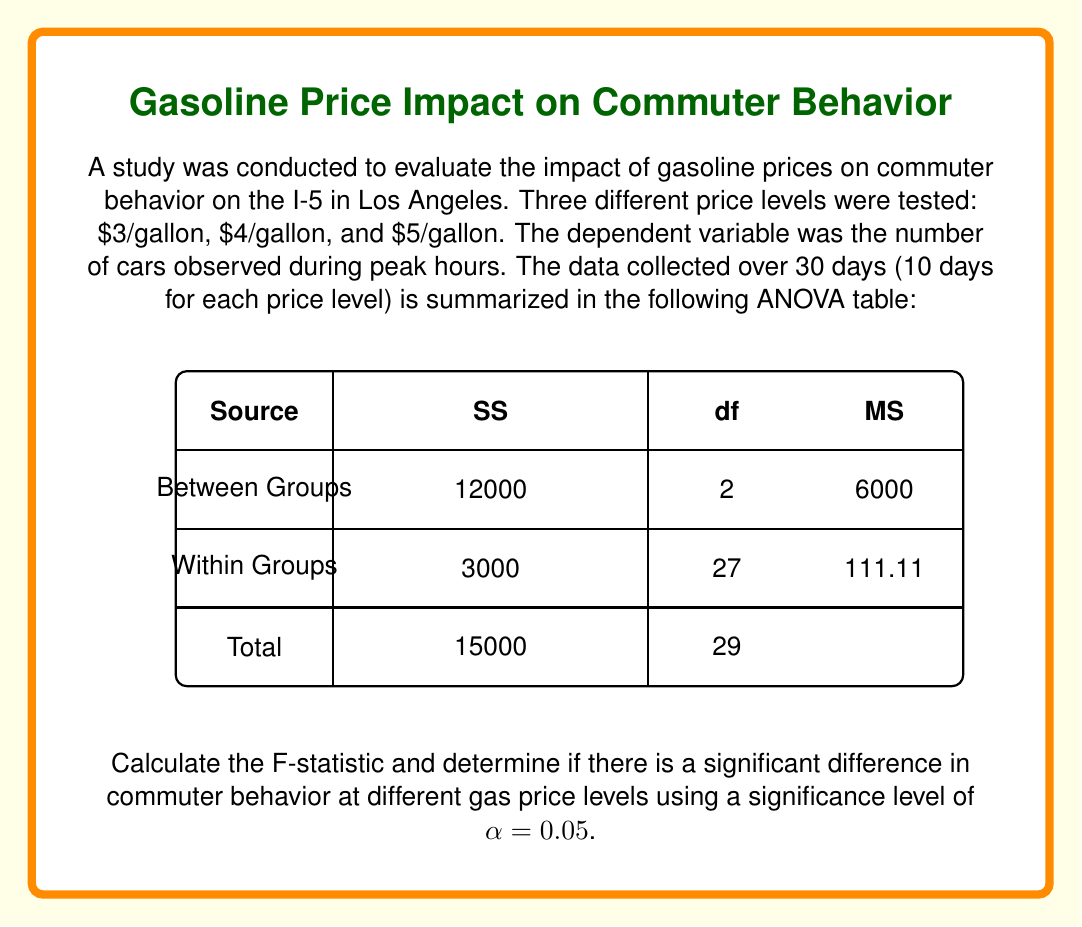Solve this math problem. To solve this problem, we'll follow these steps:

1) First, let's identify the components from the ANOVA table:
   - SS(Between) = 12000
   - SS(Within) = 3000
   - df(Between) = 2
   - df(Within) = 27
   - MS(Between) = 6000
   - MS(Within) = 111.11

2) The F-statistic is calculated as:

   $$F = \frac{MS(\text{Between})}{MS(\text{Within})}$$

3) Substituting the values:

   $$F = \frac{6000}{111.11} = 54.00$$

4) To determine if this is significant, we need to compare it to the critical F-value.

5) The critical F-value for α = 0.05, with df(numerator) = 2 and df(denominator) = 27 is approximately 3.35 (this can be found in an F-distribution table).

6) Since our calculated F-value (54.00) is greater than the critical F-value (3.35), we reject the null hypothesis.

7) This means there is a statistically significant difference in commuter behavior at different gas price levels.

The large F-value suggests that the differences between gas price levels explain a significant portion of the variability in commuter behavior, relative to the variability within each price level.
Answer: F = 54.00; Significant difference exists (p < 0.05) 